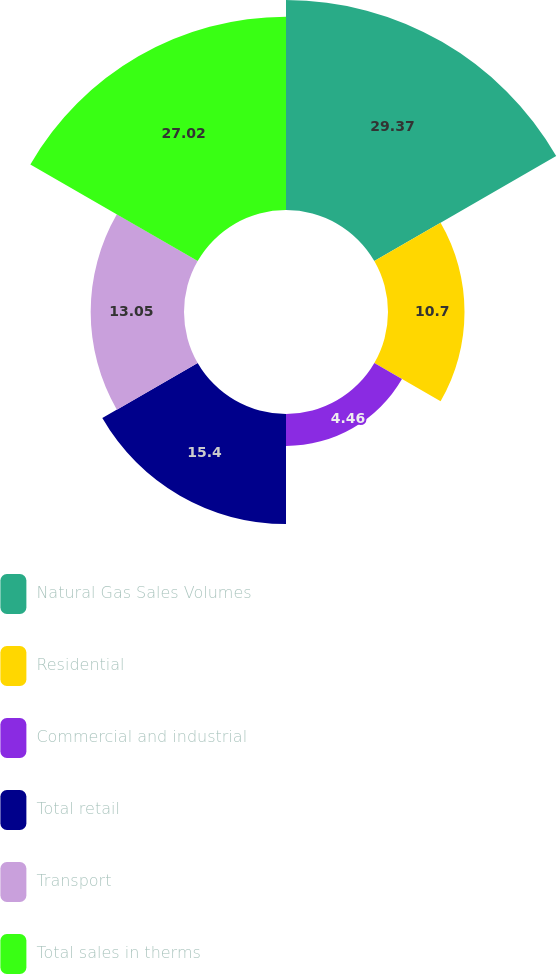<chart> <loc_0><loc_0><loc_500><loc_500><pie_chart><fcel>Natural Gas Sales Volumes<fcel>Residential<fcel>Commercial and industrial<fcel>Total retail<fcel>Transport<fcel>Total sales in therms<nl><fcel>29.37%<fcel>10.7%<fcel>4.46%<fcel>15.4%<fcel>13.05%<fcel>27.02%<nl></chart> 